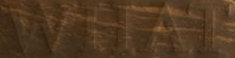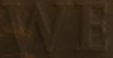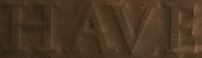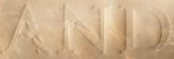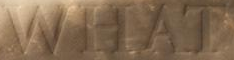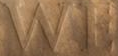What words can you see in these images in sequence, separated by a semicolon? WHAT; WE; HAVE; AND; WHAT; WE 